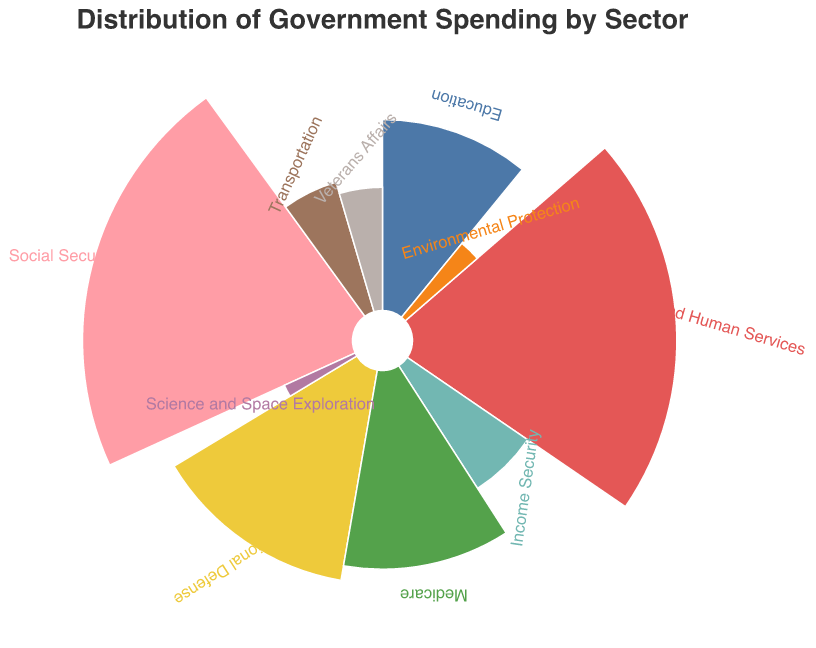What is the sector with the largest spending percentage? To determine the sector with the largest spending percentage, observe the figure and identify the sector with the largest segment of the polar chart.
Answer: Social Security Which sector receives the smallest percentage of government spending? Look for the smallest segment on the polar chart based on its size in comparison to other segments.
Answer: Science and Space Exploration How much higher is the spending on Health and Human Services compared to Transportation? Identify the percentages for both categories: 23% for Health and Human Services and 6% for Transportation. Subtract the smaller percentage from the larger one: 23 - 6 = 17.
Answer: 17% What is the combined percentage of the three sectors with the largest spending? Identify the top three largest sectors by their segments: Social Security (24%), Health and Human Services (23%), and Medicare (13%). Add their percentages: 24 + 23 + 13 = 60.
Answer: 60% Which two sectors have an equal distribution of government spending? Observe the segments of the polar chart to identify any two sectors with the same percentage.
Answer: Social Security and Health and Human Services By how much does the spending in Education differ from spending in National Defense? Identify the percentages for both categories: Education (12%) and National Defense (15%). Subtract the smaller percentage from the larger one: 15 - 12 = 3.
Answer: 3% How many sectors have a spending percentage below 10%? Identify and count the sectors on the polar chart with percentages below 10%. The sectors are Transportation (6%), Veterans Affairs (5%), Income Security (7%), Environmental Protection (3%), and Science and Space Exploration (2%).
Answer: 5 What is the average spending percentage across all sectors? Add all the percentages together and divide by the number of sectors: (23+15+12+24+6+5+7+13+3+2)/10 = 110/10 = 11.
Answer: 11% Which sector has a budget closest in percentage to Veterans Affairs? Identify the percentage for Veterans Affairs (5%) and compare it to the other sectors to find the closest value. The closest percentage is Transportation (6%).
Answer: Transportation What portion of the budget is spent on Income Security and Science and Space Exploration combined? Add the percentages for Income Security (7%) and Science and Space Exploration (2%): 7 + 2 = 9.
Answer: 9% 